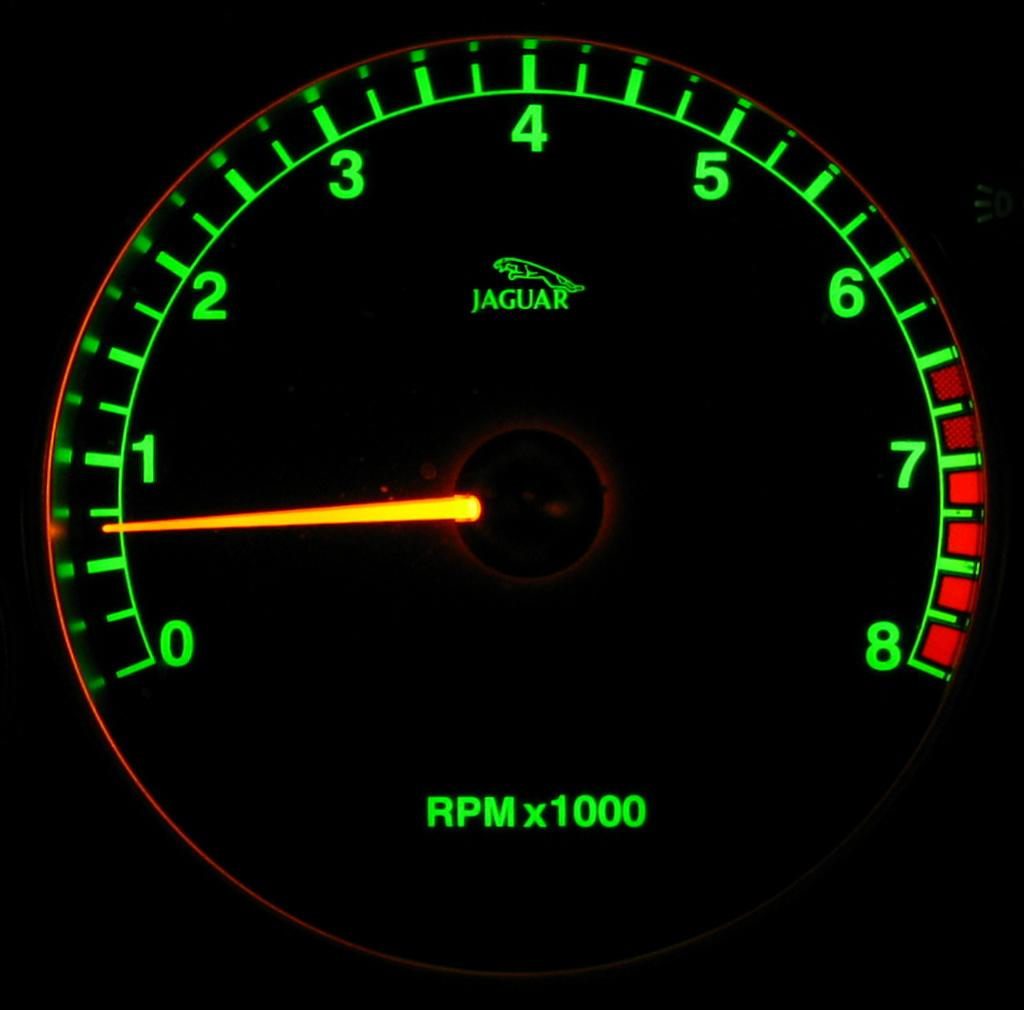What is the main subject of the image? The main subject of the image is a close view of the RPM meter. What type of car does the RPM meter belong to? The RPM meter belongs to a Jaguar car. How many girls are knitting with yarn in the image? There are no girls or yarn present in the image; it shows a close view of the RPM meter of a Jaguar car. 